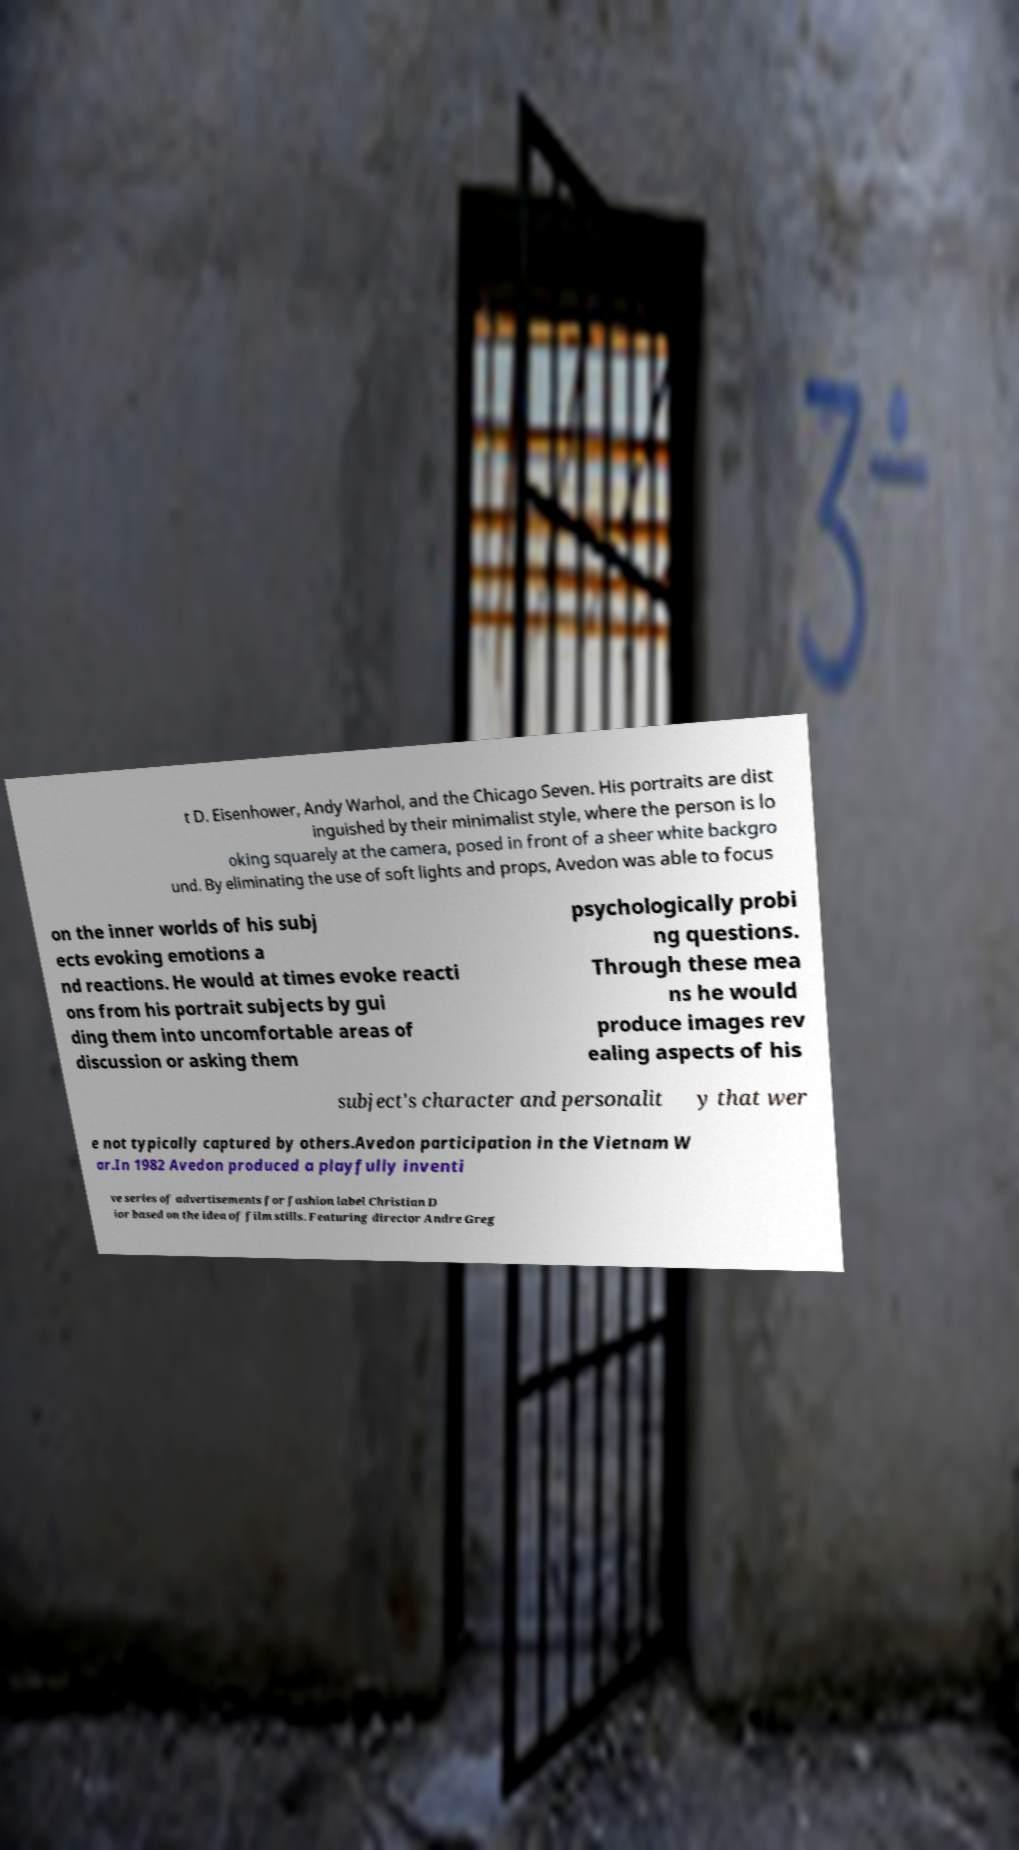There's text embedded in this image that I need extracted. Can you transcribe it verbatim? t D. Eisenhower, Andy Warhol, and the Chicago Seven. His portraits are dist inguished by their minimalist style, where the person is lo oking squarely at the camera, posed in front of a sheer white backgro und. By eliminating the use of soft lights and props, Avedon was able to focus on the inner worlds of his subj ects evoking emotions a nd reactions. He would at times evoke reacti ons from his portrait subjects by gui ding them into uncomfortable areas of discussion or asking them psychologically probi ng questions. Through these mea ns he would produce images rev ealing aspects of his subject's character and personalit y that wer e not typically captured by others.Avedon participation in the Vietnam W ar.In 1982 Avedon produced a playfully inventi ve series of advertisements for fashion label Christian D ior based on the idea of film stills. Featuring director Andre Greg 